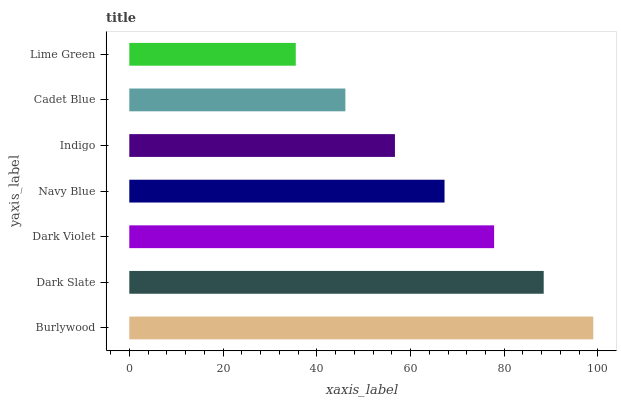Is Lime Green the minimum?
Answer yes or no. Yes. Is Burlywood the maximum?
Answer yes or no. Yes. Is Dark Slate the minimum?
Answer yes or no. No. Is Dark Slate the maximum?
Answer yes or no. No. Is Burlywood greater than Dark Slate?
Answer yes or no. Yes. Is Dark Slate less than Burlywood?
Answer yes or no. Yes. Is Dark Slate greater than Burlywood?
Answer yes or no. No. Is Burlywood less than Dark Slate?
Answer yes or no. No. Is Navy Blue the high median?
Answer yes or no. Yes. Is Navy Blue the low median?
Answer yes or no. Yes. Is Dark Violet the high median?
Answer yes or no. No. Is Dark Violet the low median?
Answer yes or no. No. 